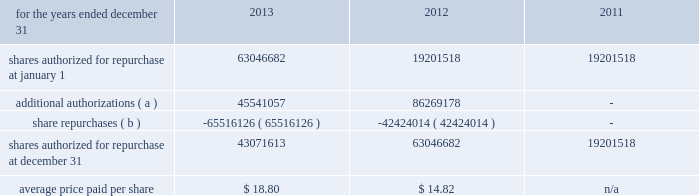Management 2019s discussion and analysis of financial condition and results of operations 82 fifth third bancorp to 100 million shares of its outstanding common stock in the open market or in privately negotiated transactions , and to utilize any derivative or similar instrument to affect share repurchase transactions .
This share repurchase authorization replaced the board 2019s previous authorization .
On may 21 , 2013 , the bancorp entered into an accelerated share repurchase transaction with a counterparty pursuant to which the bancorp purchased 25035519 shares , or approximately $ 539 million , of its outstanding common stock on may 24 , 2013 .
The bancorp repurchased the shares of its common stock as part of its 100 million share repurchase program previously announced on march 19 , 2013 .
At settlement of the forward contract on october 1 , 2013 , the bancorp received an additional 4270250 shares which were recorded as an adjustment to the basis in the treasury shares purchased on the acquisition date .
On november 13 , 2013 , the bancorp entered into an accelerated share repurchase transaction with a counterparty pursuant to which the bancorp purchased 8538423 shares , or approximately $ 200 million , of its outstanding common stock on november 18 , 2013 .
The bancorp repurchased the shares of its common stock as part of its board approved 100 million share repurchase program previously announced on march 19 , 2013 .
The bancorp expects the settlement of the transaction to occur on or before february 28 , 2014 .
On december 10 , 2013 , the bancorp entered into an accelerated share repurchase transaction with a counterparty pursuant to which the bancorp purchased 19084195 shares , or approximately $ 456 million , of its outstanding common stock on december 13 , 2013 .
The bancorp repurchased the shares of its common stock as part of its board approved 100 million share repurchase program previously announced on march 19 , 2013 .
The bancorp expects the settlement of the transaction to occur on or before march 26 , 2014 .
On january 28 , 2014 , the bancorp entered into an accelerated share repurchase transaction with a counterparty pursuant to which the bancorp purchased 3950705 shares , or approximately $ 99 million , of its outstanding common stock on january 31 , 2014 .
The bancorp repurchased the shares of its common stock as part of its board approved 100 million share repurchase program previously announced on march 19 , 2013 .
The bancorp expects the settlement of the transaction to occur on or before march 26 , 2014 .
Table 61 : share repurchases .
( a ) in march 2013 , the bancorp announced that its board of directors had authorized management to purchase 100 million shares of the bancorp 2019s common stock through the open market or in any private transaction .
The authorization does not include specific price targets or an expiration date .
This share repurchase authorization replaces the board 2019s previous authorization pursuant to which approximately 54 million shares remained available for repurchase by the bancorp .
( b ) excludes 1863097 , 2059003 and 1164254 shares repurchased during 2013 , 2012 , and 2011 , respectively , in connection with various employee compensation plans .
These repurchases are not included in the calculation for average price paid and do not count against the maximum number of shares that may yet be repurchased under the board of directors 2019 authorization .
Stress tests and ccar the frb issued guidelines known as ccar , which provide a common , conservative approach to ensure bhcs , including the bancorp , hold adequate capital to maintain ready access to funding , continue operations and meet their obligations to creditors and counterparties , and continue to serve as credit intermediaries , even in adverse conditions .
The ccar process requires the submission of a comprehensive capital plan that assumes a minimum planning horizon of nine quarters under various economic scenarios .
The mandatory elements of the capital plan are an assessment of the expected use and sources of capital over the planning horizon , a description of all planned capital actions over the planning horizon , a discussion of any expected changes to the bancorp 2019s business plan that are likely to have a material impact on its capital adequacy or liquidity , a detailed description of the bancorp 2019s process for assessing capital adequacy and the bancorp 2019s capital policy .
The capital plan must reflect the revised capital framework that the frb adopted in connection with the implementation of the basel iii accord , including the framework 2019s minimum regulatory capital ratios and transition arrangements .
The frb 2019s review of the capital plan will assess the comprehensiveness of the capital plan , the reasonableness of the assumptions and the analysis underlying the capital plan .
Additionally , the frb reviews the robustness of the capital adequacy process , the capital policy and the bancorp 2019s ability to maintain capital above the minimum regulatory capital ratios as they transition to basel iii and above a basel i tier 1 common ratio of 5 percent under baseline and stressful conditions throughout a nine- quarter planning horizon .
The frb issued stress testing rules that implement section 165 ( i ) ( 1 ) and ( i ) ( 2 ) of the dfa .
Large bhcs , including the bancorp , are subject to the final stress testing rules .
The rules require both supervisory and company-run stress tests , which provide forward- looking information to supervisors to help assess whether institutions have sufficient capital to absorb losses and support operations during adverse economic conditions .
In march of 2013 , the frb announced it had completed the 2013 ccar .
For bhcs that proposed capital distributions in their plan , the frb either objected to the plan or provided a non- objection whereby the frb concurred with the proposed 2013 capital distributions .
The frb indicated to the bancorp that it did not object to the following proposed capital actions for the period beginning april 1 , 2013 and ending march 31 , 2014 : f0b7 increase in the quarterly common stock dividend to $ 0.12 per share ; f0b7 repurchase of up to $ 750 million in trups subject to the determination of a regulatory capital event and replacement with the issuance of a similar amount of tier ii-qualifying subordinated debt ; f0b7 conversion of the $ 398 million in outstanding series g 8.5% ( 8.5 % ) convertible preferred stock into approximately 35.5 million common shares issued to the holders .
If this conversion were to occur , the bancorp would intend to repurchase common shares equivalent to those issued in the conversion up to $ 550 million in market value , and issue $ 550 million in preferred stock; .
What percent of the total authorized share repurchase was completed by the may 21 , 2013 share repurchase transaction?\\n\\n? 
Computations: (25035519 / (100 * 1000000))
Answer: 0.25036. Management 2019s discussion and analysis of financial condition and results of operations 82 fifth third bancorp to 100 million shares of its outstanding common stock in the open market or in privately negotiated transactions , and to utilize any derivative or similar instrument to affect share repurchase transactions .
This share repurchase authorization replaced the board 2019s previous authorization .
On may 21 , 2013 , the bancorp entered into an accelerated share repurchase transaction with a counterparty pursuant to which the bancorp purchased 25035519 shares , or approximately $ 539 million , of its outstanding common stock on may 24 , 2013 .
The bancorp repurchased the shares of its common stock as part of its 100 million share repurchase program previously announced on march 19 , 2013 .
At settlement of the forward contract on october 1 , 2013 , the bancorp received an additional 4270250 shares which were recorded as an adjustment to the basis in the treasury shares purchased on the acquisition date .
On november 13 , 2013 , the bancorp entered into an accelerated share repurchase transaction with a counterparty pursuant to which the bancorp purchased 8538423 shares , or approximately $ 200 million , of its outstanding common stock on november 18 , 2013 .
The bancorp repurchased the shares of its common stock as part of its board approved 100 million share repurchase program previously announced on march 19 , 2013 .
The bancorp expects the settlement of the transaction to occur on or before february 28 , 2014 .
On december 10 , 2013 , the bancorp entered into an accelerated share repurchase transaction with a counterparty pursuant to which the bancorp purchased 19084195 shares , or approximately $ 456 million , of its outstanding common stock on december 13 , 2013 .
The bancorp repurchased the shares of its common stock as part of its board approved 100 million share repurchase program previously announced on march 19 , 2013 .
The bancorp expects the settlement of the transaction to occur on or before march 26 , 2014 .
On january 28 , 2014 , the bancorp entered into an accelerated share repurchase transaction with a counterparty pursuant to which the bancorp purchased 3950705 shares , or approximately $ 99 million , of its outstanding common stock on january 31 , 2014 .
The bancorp repurchased the shares of its common stock as part of its board approved 100 million share repurchase program previously announced on march 19 , 2013 .
The bancorp expects the settlement of the transaction to occur on or before march 26 , 2014 .
Table 61 : share repurchases .
( a ) in march 2013 , the bancorp announced that its board of directors had authorized management to purchase 100 million shares of the bancorp 2019s common stock through the open market or in any private transaction .
The authorization does not include specific price targets or an expiration date .
This share repurchase authorization replaces the board 2019s previous authorization pursuant to which approximately 54 million shares remained available for repurchase by the bancorp .
( b ) excludes 1863097 , 2059003 and 1164254 shares repurchased during 2013 , 2012 , and 2011 , respectively , in connection with various employee compensation plans .
These repurchases are not included in the calculation for average price paid and do not count against the maximum number of shares that may yet be repurchased under the board of directors 2019 authorization .
Stress tests and ccar the frb issued guidelines known as ccar , which provide a common , conservative approach to ensure bhcs , including the bancorp , hold adequate capital to maintain ready access to funding , continue operations and meet their obligations to creditors and counterparties , and continue to serve as credit intermediaries , even in adverse conditions .
The ccar process requires the submission of a comprehensive capital plan that assumes a minimum planning horizon of nine quarters under various economic scenarios .
The mandatory elements of the capital plan are an assessment of the expected use and sources of capital over the planning horizon , a description of all planned capital actions over the planning horizon , a discussion of any expected changes to the bancorp 2019s business plan that are likely to have a material impact on its capital adequacy or liquidity , a detailed description of the bancorp 2019s process for assessing capital adequacy and the bancorp 2019s capital policy .
The capital plan must reflect the revised capital framework that the frb adopted in connection with the implementation of the basel iii accord , including the framework 2019s minimum regulatory capital ratios and transition arrangements .
The frb 2019s review of the capital plan will assess the comprehensiveness of the capital plan , the reasonableness of the assumptions and the analysis underlying the capital plan .
Additionally , the frb reviews the robustness of the capital adequacy process , the capital policy and the bancorp 2019s ability to maintain capital above the minimum regulatory capital ratios as they transition to basel iii and above a basel i tier 1 common ratio of 5 percent under baseline and stressful conditions throughout a nine- quarter planning horizon .
The frb issued stress testing rules that implement section 165 ( i ) ( 1 ) and ( i ) ( 2 ) of the dfa .
Large bhcs , including the bancorp , are subject to the final stress testing rules .
The rules require both supervisory and company-run stress tests , which provide forward- looking information to supervisors to help assess whether institutions have sufficient capital to absorb losses and support operations during adverse economic conditions .
In march of 2013 , the frb announced it had completed the 2013 ccar .
For bhcs that proposed capital distributions in their plan , the frb either objected to the plan or provided a non- objection whereby the frb concurred with the proposed 2013 capital distributions .
The frb indicated to the bancorp that it did not object to the following proposed capital actions for the period beginning april 1 , 2013 and ending march 31 , 2014 : f0b7 increase in the quarterly common stock dividend to $ 0.12 per share ; f0b7 repurchase of up to $ 750 million in trups subject to the determination of a regulatory capital event and replacement with the issuance of a similar amount of tier ii-qualifying subordinated debt ; f0b7 conversion of the $ 398 million in outstanding series g 8.5% ( 8.5 % ) convertible preferred stock into approximately 35.5 million common shares issued to the holders .
If this conversion were to occur , the bancorp would intend to repurchase common shares equivalent to those issued in the conversion up to $ 550 million in market value , and issue $ 550 million in preferred stock; .
What were total share repurchases for 2013 including the employee compensation plans repurchases? 
Computations: (1863097 + 65516126)
Answer: 67379223.0. Management 2019s discussion and analysis of financial condition and results of operations 82 fifth third bancorp to 100 million shares of its outstanding common stock in the open market or in privately negotiated transactions , and to utilize any derivative or similar instrument to affect share repurchase transactions .
This share repurchase authorization replaced the board 2019s previous authorization .
On may 21 , 2013 , the bancorp entered into an accelerated share repurchase transaction with a counterparty pursuant to which the bancorp purchased 25035519 shares , or approximately $ 539 million , of its outstanding common stock on may 24 , 2013 .
The bancorp repurchased the shares of its common stock as part of its 100 million share repurchase program previously announced on march 19 , 2013 .
At settlement of the forward contract on october 1 , 2013 , the bancorp received an additional 4270250 shares which were recorded as an adjustment to the basis in the treasury shares purchased on the acquisition date .
On november 13 , 2013 , the bancorp entered into an accelerated share repurchase transaction with a counterparty pursuant to which the bancorp purchased 8538423 shares , or approximately $ 200 million , of its outstanding common stock on november 18 , 2013 .
The bancorp repurchased the shares of its common stock as part of its board approved 100 million share repurchase program previously announced on march 19 , 2013 .
The bancorp expects the settlement of the transaction to occur on or before february 28 , 2014 .
On december 10 , 2013 , the bancorp entered into an accelerated share repurchase transaction with a counterparty pursuant to which the bancorp purchased 19084195 shares , or approximately $ 456 million , of its outstanding common stock on december 13 , 2013 .
The bancorp repurchased the shares of its common stock as part of its board approved 100 million share repurchase program previously announced on march 19 , 2013 .
The bancorp expects the settlement of the transaction to occur on or before march 26 , 2014 .
On january 28 , 2014 , the bancorp entered into an accelerated share repurchase transaction with a counterparty pursuant to which the bancorp purchased 3950705 shares , or approximately $ 99 million , of its outstanding common stock on january 31 , 2014 .
The bancorp repurchased the shares of its common stock as part of its board approved 100 million share repurchase program previously announced on march 19 , 2013 .
The bancorp expects the settlement of the transaction to occur on or before march 26 , 2014 .
Table 61 : share repurchases .
( a ) in march 2013 , the bancorp announced that its board of directors had authorized management to purchase 100 million shares of the bancorp 2019s common stock through the open market or in any private transaction .
The authorization does not include specific price targets or an expiration date .
This share repurchase authorization replaces the board 2019s previous authorization pursuant to which approximately 54 million shares remained available for repurchase by the bancorp .
( b ) excludes 1863097 , 2059003 and 1164254 shares repurchased during 2013 , 2012 , and 2011 , respectively , in connection with various employee compensation plans .
These repurchases are not included in the calculation for average price paid and do not count against the maximum number of shares that may yet be repurchased under the board of directors 2019 authorization .
Stress tests and ccar the frb issued guidelines known as ccar , which provide a common , conservative approach to ensure bhcs , including the bancorp , hold adequate capital to maintain ready access to funding , continue operations and meet their obligations to creditors and counterparties , and continue to serve as credit intermediaries , even in adverse conditions .
The ccar process requires the submission of a comprehensive capital plan that assumes a minimum planning horizon of nine quarters under various economic scenarios .
The mandatory elements of the capital plan are an assessment of the expected use and sources of capital over the planning horizon , a description of all planned capital actions over the planning horizon , a discussion of any expected changes to the bancorp 2019s business plan that are likely to have a material impact on its capital adequacy or liquidity , a detailed description of the bancorp 2019s process for assessing capital adequacy and the bancorp 2019s capital policy .
The capital plan must reflect the revised capital framework that the frb adopted in connection with the implementation of the basel iii accord , including the framework 2019s minimum regulatory capital ratios and transition arrangements .
The frb 2019s review of the capital plan will assess the comprehensiveness of the capital plan , the reasonableness of the assumptions and the analysis underlying the capital plan .
Additionally , the frb reviews the robustness of the capital adequacy process , the capital policy and the bancorp 2019s ability to maintain capital above the minimum regulatory capital ratios as they transition to basel iii and above a basel i tier 1 common ratio of 5 percent under baseline and stressful conditions throughout a nine- quarter planning horizon .
The frb issued stress testing rules that implement section 165 ( i ) ( 1 ) and ( i ) ( 2 ) of the dfa .
Large bhcs , including the bancorp , are subject to the final stress testing rules .
The rules require both supervisory and company-run stress tests , which provide forward- looking information to supervisors to help assess whether institutions have sufficient capital to absorb losses and support operations during adverse economic conditions .
In march of 2013 , the frb announced it had completed the 2013 ccar .
For bhcs that proposed capital distributions in their plan , the frb either objected to the plan or provided a non- objection whereby the frb concurred with the proposed 2013 capital distributions .
The frb indicated to the bancorp that it did not object to the following proposed capital actions for the period beginning april 1 , 2013 and ending march 31 , 2014 : f0b7 increase in the quarterly common stock dividend to $ 0.12 per share ; f0b7 repurchase of up to $ 750 million in trups subject to the determination of a regulatory capital event and replacement with the issuance of a similar amount of tier ii-qualifying subordinated debt ; f0b7 conversion of the $ 398 million in outstanding series g 8.5% ( 8.5 % ) convertible preferred stock into approximately 35.5 million common shares issued to the holders .
If this conversion were to occur , the bancorp would intend to repurchase common shares equivalent to those issued in the conversion up to $ 550 million in market value , and issue $ 550 million in preferred stock; .
What is the growth rate in the average price paid per share from 2012 to 2013? 
Computations: ((18.80 - 14.82) / 14.82)
Answer: 0.26856. 